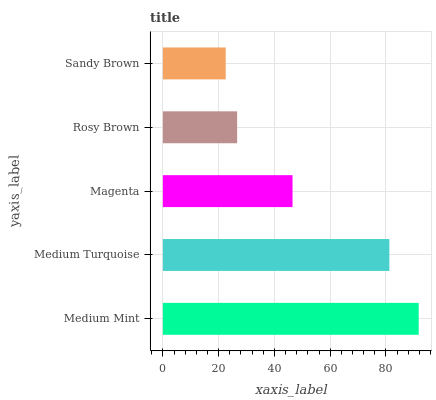Is Sandy Brown the minimum?
Answer yes or no. Yes. Is Medium Mint the maximum?
Answer yes or no. Yes. Is Medium Turquoise the minimum?
Answer yes or no. No. Is Medium Turquoise the maximum?
Answer yes or no. No. Is Medium Mint greater than Medium Turquoise?
Answer yes or no. Yes. Is Medium Turquoise less than Medium Mint?
Answer yes or no. Yes. Is Medium Turquoise greater than Medium Mint?
Answer yes or no. No. Is Medium Mint less than Medium Turquoise?
Answer yes or no. No. Is Magenta the high median?
Answer yes or no. Yes. Is Magenta the low median?
Answer yes or no. Yes. Is Sandy Brown the high median?
Answer yes or no. No. Is Medium Turquoise the low median?
Answer yes or no. No. 